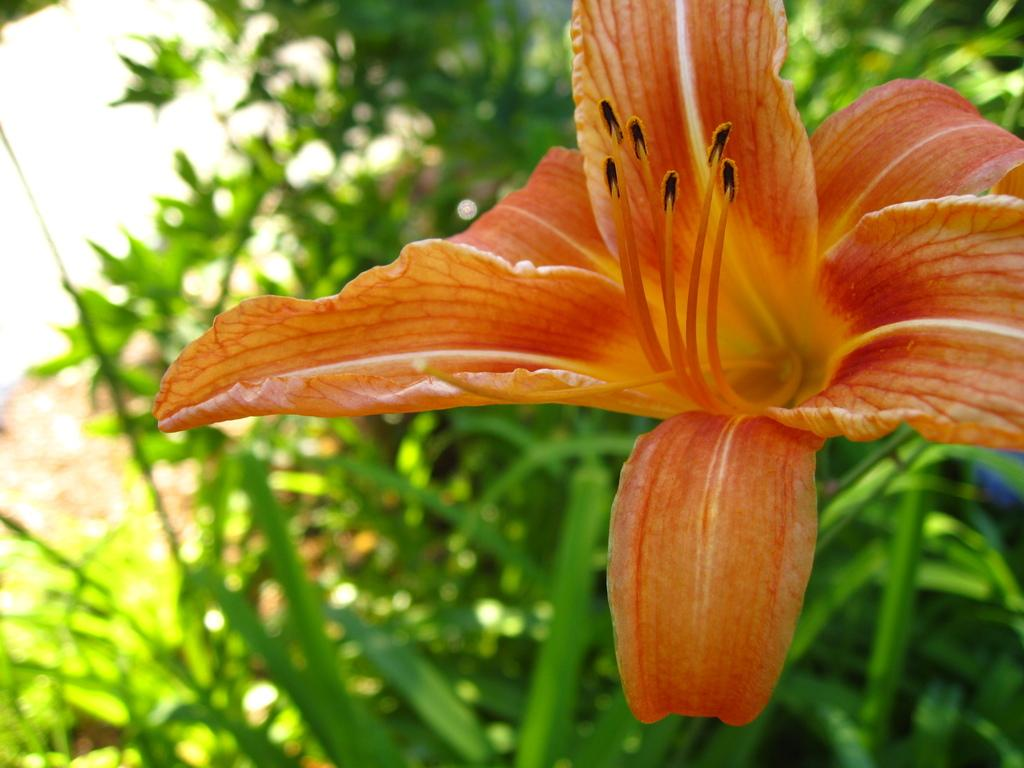What type of flower can be seen in the foreground of the image? There is an orange-colored flower on a plant in the foreground of the image. What else can be seen in the foreground of the image? The orange-colored flower is on a plant. What is visible in the background of the image? There are plants in the background of the image. What type of pollution can be seen in the image? There is no indication of pollution in the image; it features a flower and plants. How many patches are visible on the flower in the image? The flower in the image is orange-colored and does not have any visible patches. 